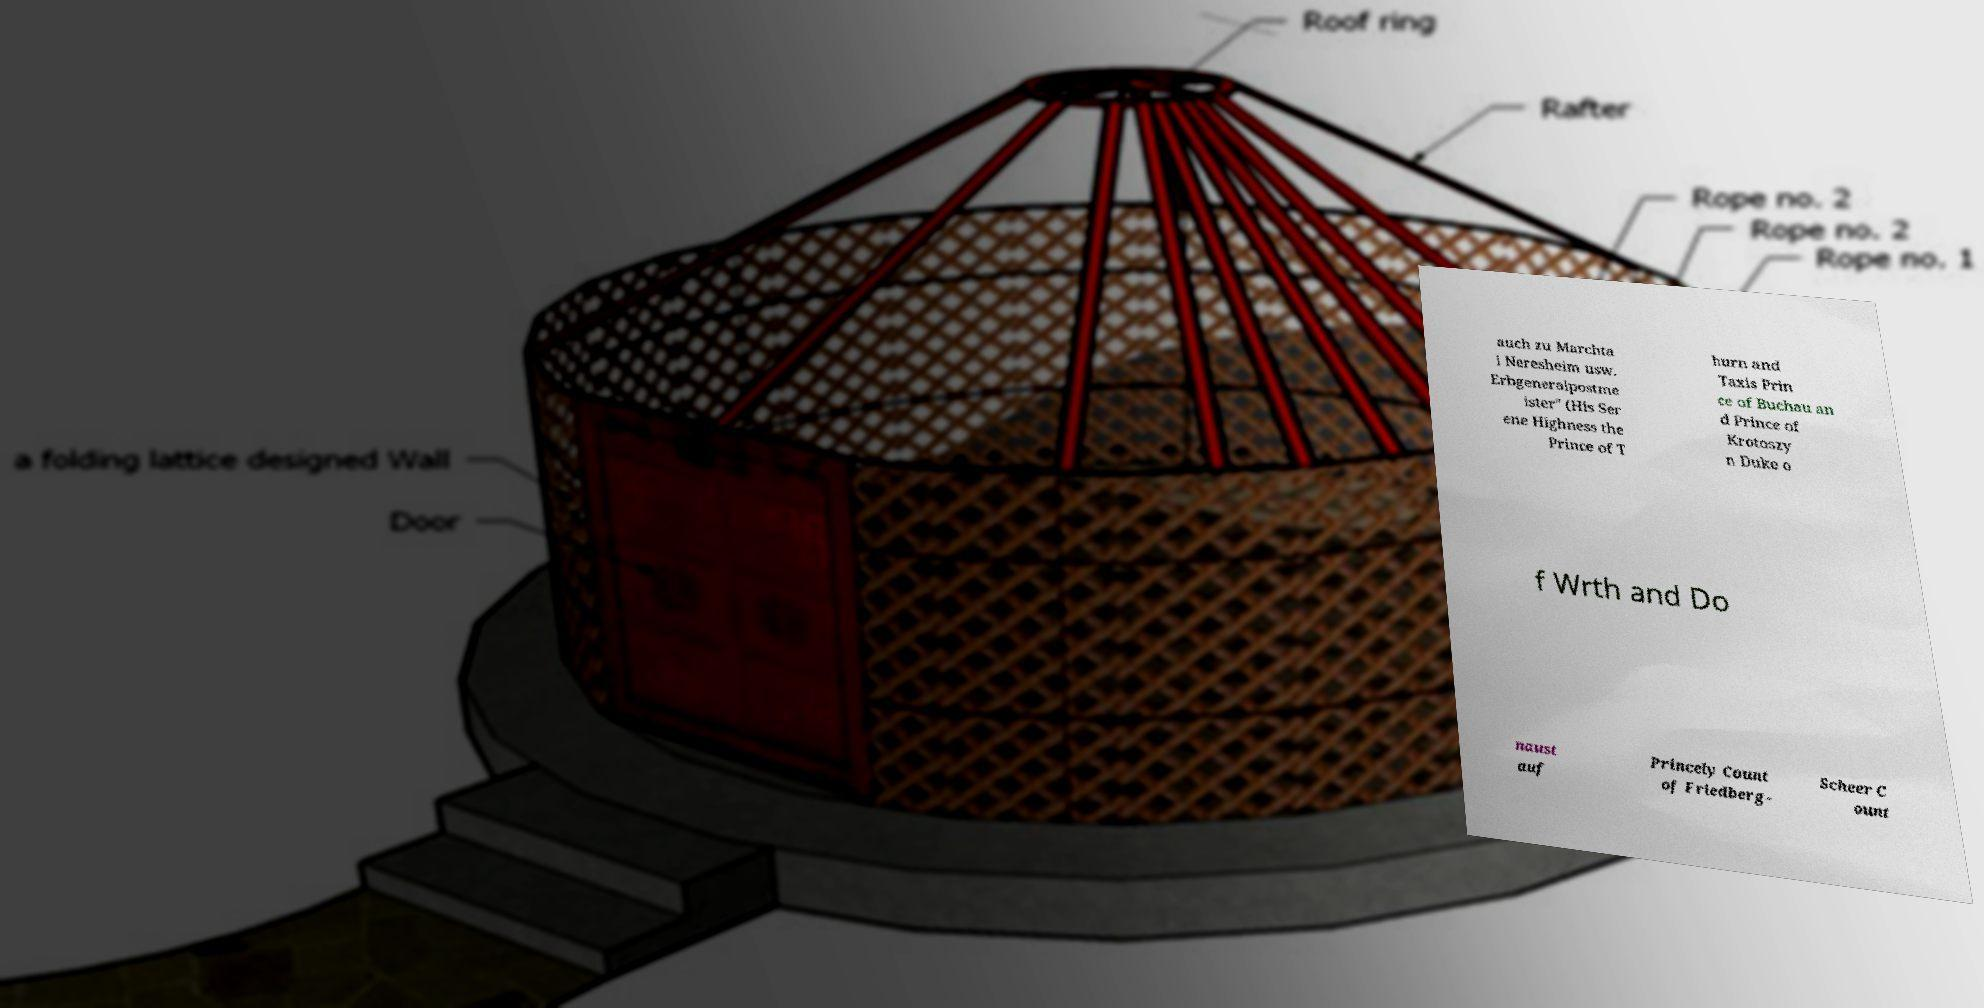Please read and relay the text visible in this image. What does it say? auch zu Marchta l Neresheim usw. Erbgeneralpostme ister" (His Ser ene Highness the Prince of T hurn and Taxis Prin ce of Buchau an d Prince of Krotoszy n Duke o f Wrth and Do naust auf Princely Count of Friedberg- Scheer C ount 